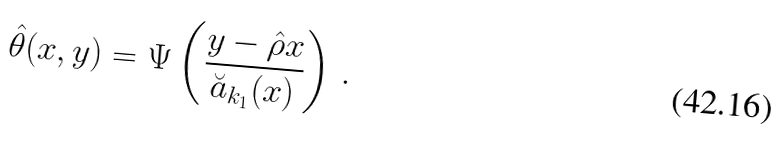<formula> <loc_0><loc_0><loc_500><loc_500>\hat { \theta } ( x , y ) = \Psi \left ( \frac { y - \hat { \rho } x } { \breve { a } _ { k _ { 1 } } ( x ) } \right ) \, .</formula> 